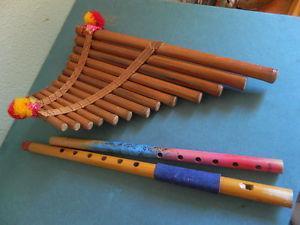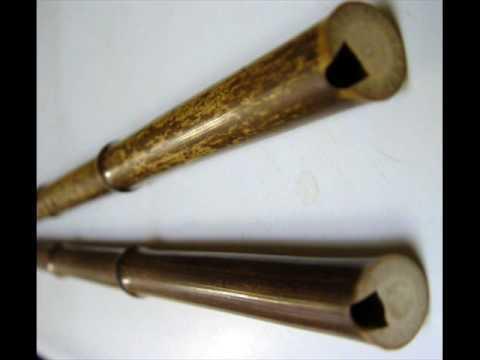The first image is the image on the left, the second image is the image on the right. Assess this claim about the two images: "In at least one image there are two small flutes.". Correct or not? Answer yes or no. Yes. 